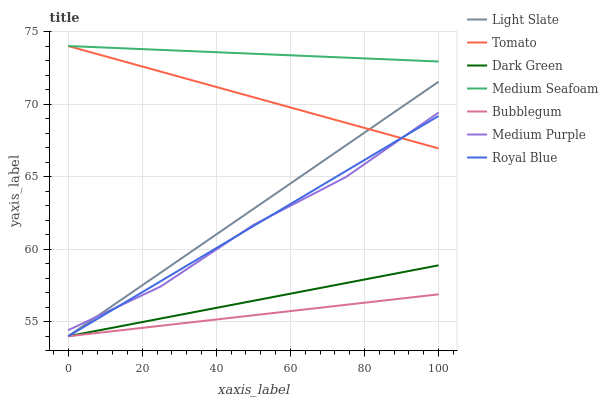Does Bubblegum have the minimum area under the curve?
Answer yes or no. Yes. Does Medium Seafoam have the maximum area under the curve?
Answer yes or no. Yes. Does Light Slate have the minimum area under the curve?
Answer yes or no. No. Does Light Slate have the maximum area under the curve?
Answer yes or no. No. Is Bubblegum the smoothest?
Answer yes or no. Yes. Is Medium Purple the roughest?
Answer yes or no. Yes. Is Light Slate the smoothest?
Answer yes or no. No. Is Light Slate the roughest?
Answer yes or no. No. Does Light Slate have the lowest value?
Answer yes or no. Yes. Does Medium Purple have the lowest value?
Answer yes or no. No. Does Medium Seafoam have the highest value?
Answer yes or no. Yes. Does Light Slate have the highest value?
Answer yes or no. No. Is Dark Green less than Medium Purple?
Answer yes or no. Yes. Is Medium Seafoam greater than Dark Green?
Answer yes or no. Yes. Does Light Slate intersect Bubblegum?
Answer yes or no. Yes. Is Light Slate less than Bubblegum?
Answer yes or no. No. Is Light Slate greater than Bubblegum?
Answer yes or no. No. Does Dark Green intersect Medium Purple?
Answer yes or no. No. 